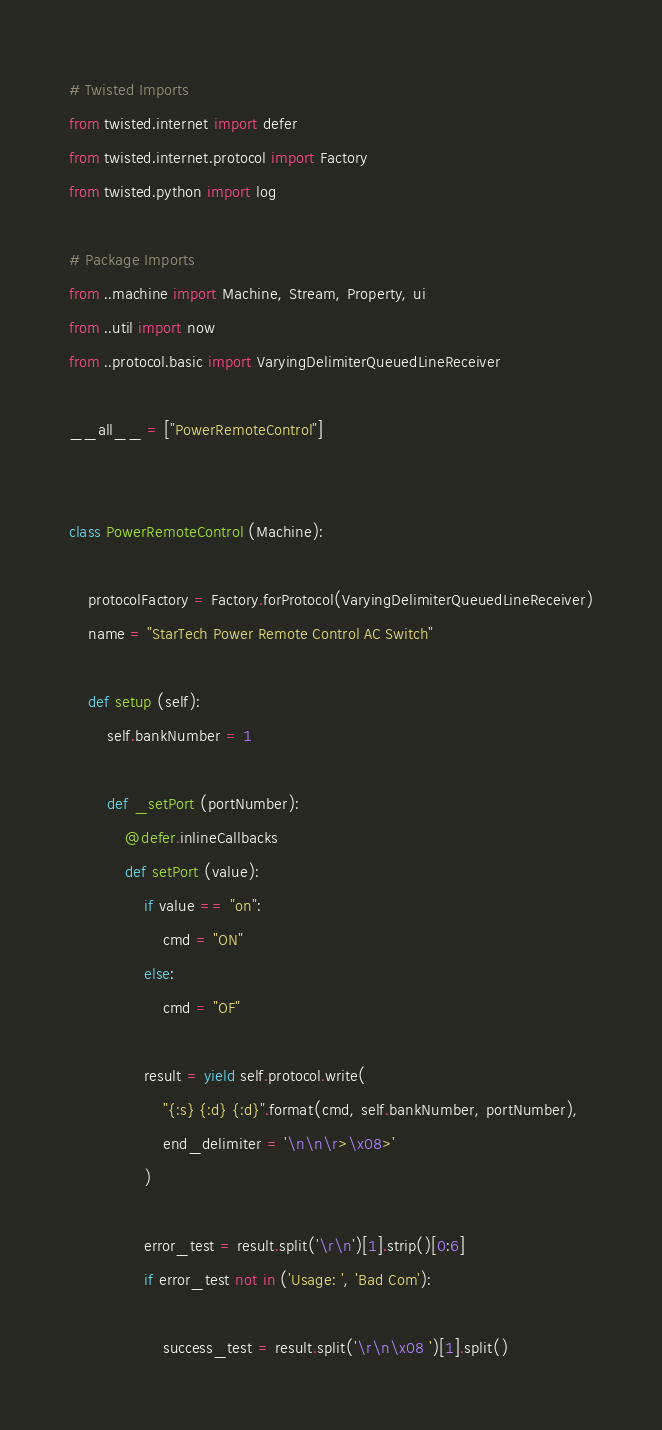<code> <loc_0><loc_0><loc_500><loc_500><_Python_># Twisted Imports
from twisted.internet import defer
from twisted.internet.protocol import Factory
from twisted.python import log

# Package Imports
from ..machine import Machine, Stream, Property, ui
from ..util import now
from ..protocol.basic import VaryingDelimiterQueuedLineReceiver

__all__ = ["PowerRemoteControl"]


class PowerRemoteControl (Machine):

	protocolFactory = Factory.forProtocol(VaryingDelimiterQueuedLineReceiver)
	name = "StarTech Power Remote Control AC Switch"

	def setup (self):
		self.bankNumber = 1

		def _setPort (portNumber):
			@defer.inlineCallbacks
			def setPort (value):
				if value == "on":
					cmd = "ON"
				else:
					cmd = "OF"

				result = yield self.protocol.write(
					"{:s} {:d} {:d}".format(cmd, self.bankNumber, portNumber),
					end_delimiter = '\n\n\r>\x08>'
				)

				error_test = result.split('\r\n')[1].strip()[0:6]
				if error_test not in ('Usage: ', 'Bad Com'):

					success_test = result.split('\r\n\x08 ')[1].split()
</code> 